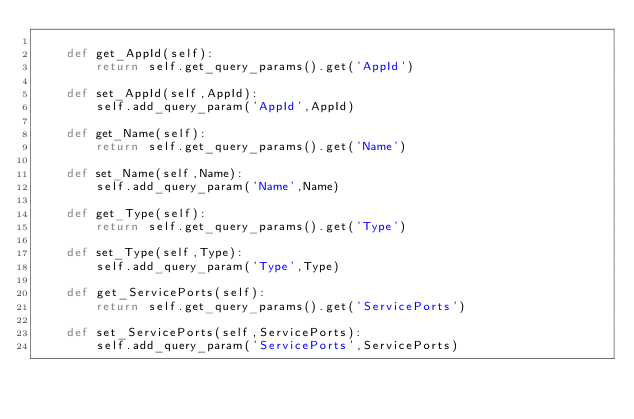Convert code to text. <code><loc_0><loc_0><loc_500><loc_500><_Python_>
	def get_AppId(self):
		return self.get_query_params().get('AppId')

	def set_AppId(self,AppId):
		self.add_query_param('AppId',AppId)

	def get_Name(self):
		return self.get_query_params().get('Name')

	def set_Name(self,Name):
		self.add_query_param('Name',Name)

	def get_Type(self):
		return self.get_query_params().get('Type')

	def set_Type(self,Type):
		self.add_query_param('Type',Type)

	def get_ServicePorts(self):
		return self.get_query_params().get('ServicePorts')

	def set_ServicePorts(self,ServicePorts):
		self.add_query_param('ServicePorts',ServicePorts)</code> 